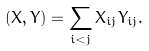<formula> <loc_0><loc_0><loc_500><loc_500>( X , Y ) = \sum _ { i < j } X _ { i j } Y _ { i j } .</formula> 